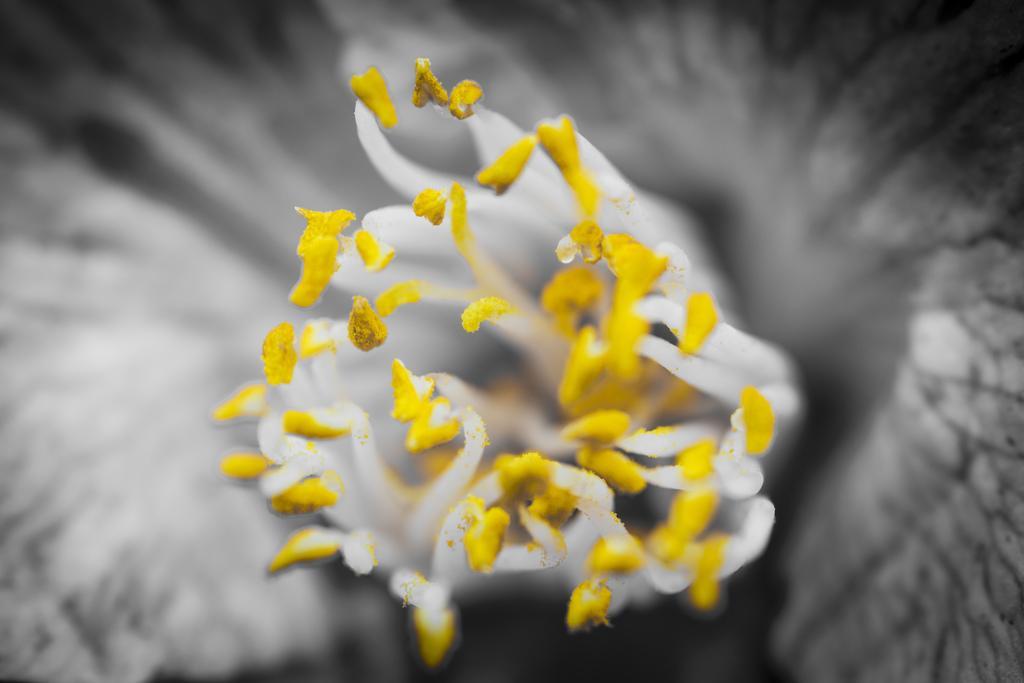How would you summarize this image in a sentence or two? In this picture we can see white and yellow color flower. 